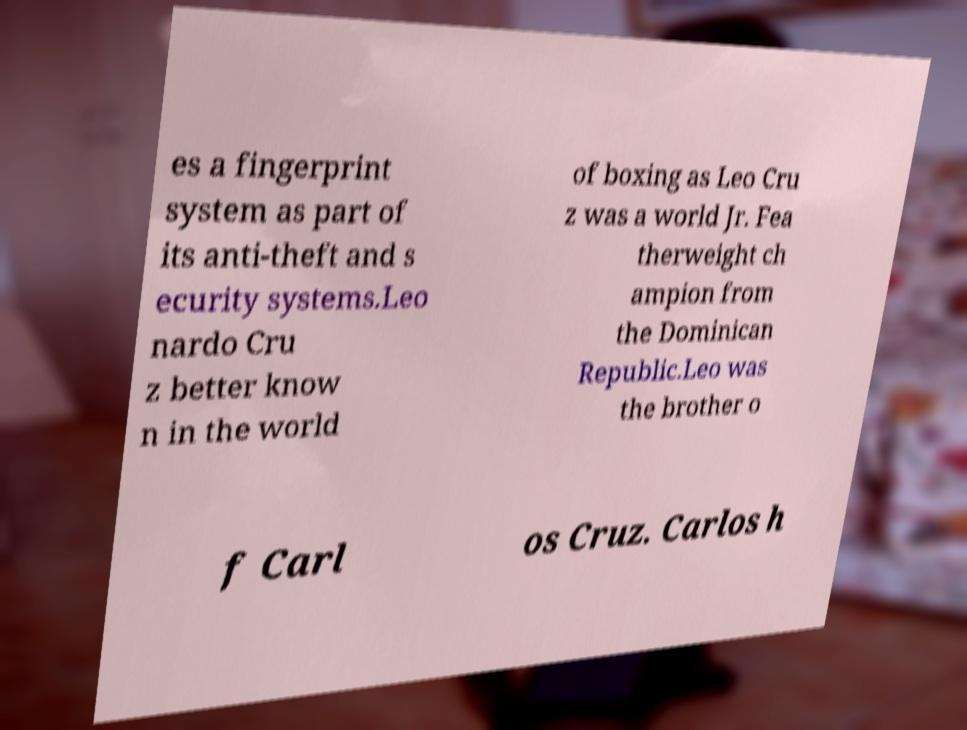Could you assist in decoding the text presented in this image and type it out clearly? es a fingerprint system as part of its anti-theft and s ecurity systems.Leo nardo Cru z better know n in the world of boxing as Leo Cru z was a world Jr. Fea therweight ch ampion from the Dominican Republic.Leo was the brother o f Carl os Cruz. Carlos h 